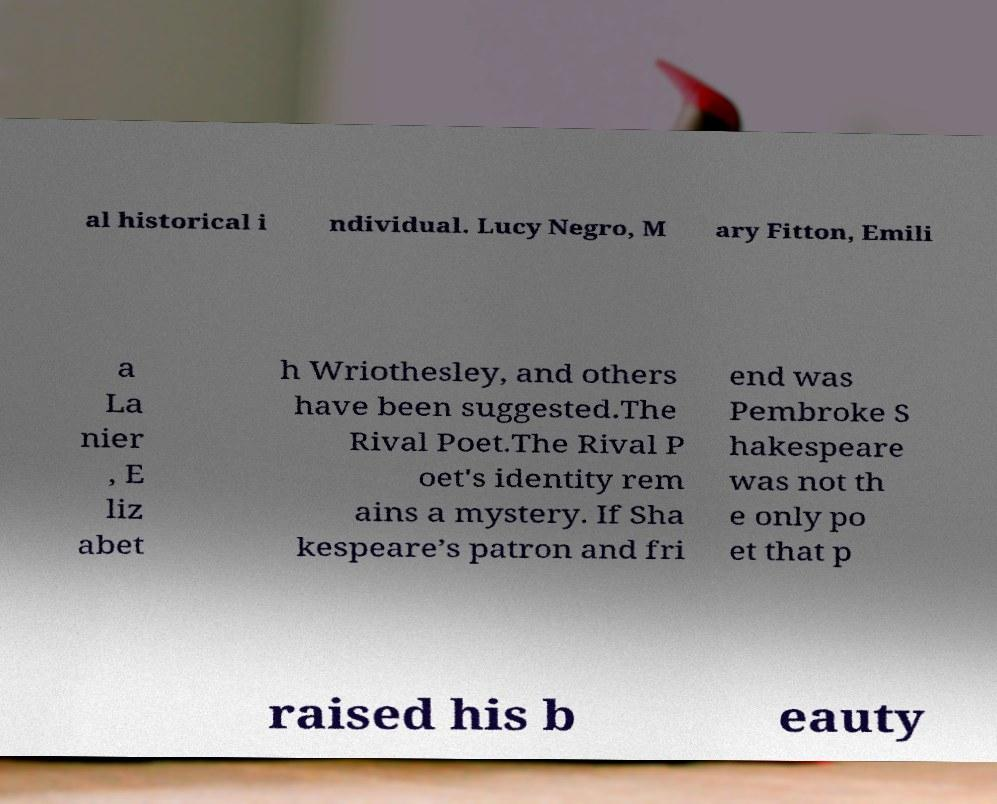For documentation purposes, I need the text within this image transcribed. Could you provide that? al historical i ndividual. Lucy Negro, M ary Fitton, Emili a La nier , E liz abet h Wriothesley, and others have been suggested.The Rival Poet.The Rival P oet's identity rem ains a mystery. If Sha kespeare’s patron and fri end was Pembroke S hakespeare was not th e only po et that p raised his b eauty 